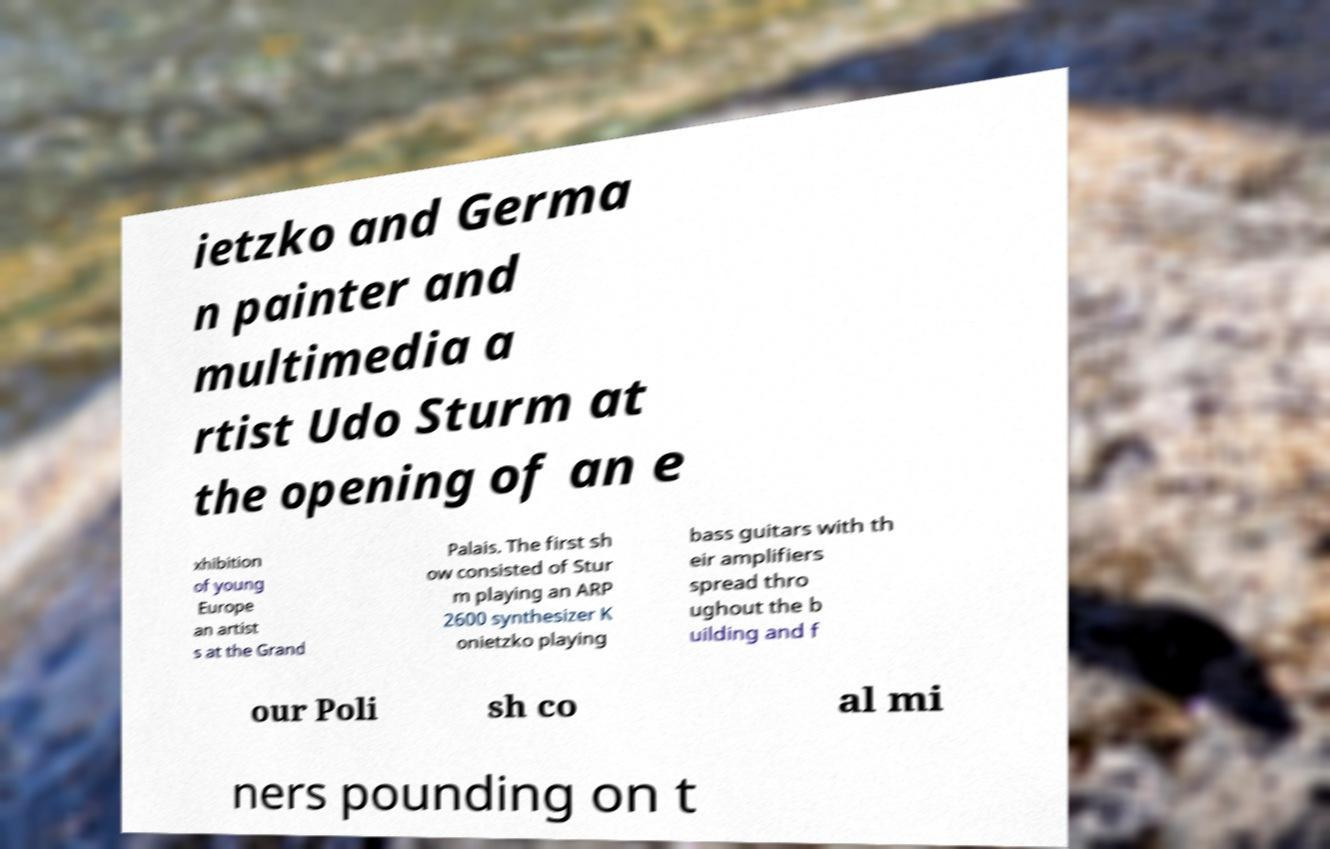Can you accurately transcribe the text from the provided image for me? ietzko and Germa n painter and multimedia a rtist Udo Sturm at the opening of an e xhibition of young Europe an artist s at the Grand Palais. The first sh ow consisted of Stur m playing an ARP 2600 synthesizer K onietzko playing bass guitars with th eir amplifiers spread thro ughout the b uilding and f our Poli sh co al mi ners pounding on t 